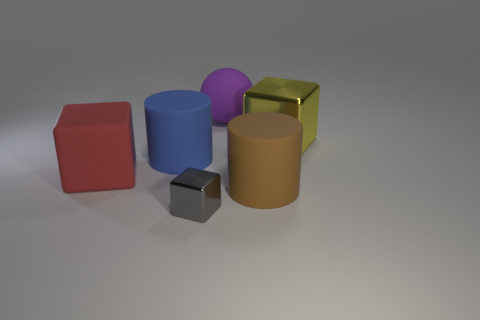What material is the large cylinder that is to the left of the big purple sphere?
Ensure brevity in your answer.  Rubber. Does the object that is on the right side of the brown cylinder have the same shape as the purple thing?
Provide a succinct answer. No. Is there a shiny thing of the same size as the matte ball?
Your answer should be compact. Yes. Is the shape of the small thing the same as the metal thing behind the large brown rubber thing?
Keep it short and to the point. Yes. Are there fewer large brown cylinders that are in front of the big purple rubber object than red rubber balls?
Provide a succinct answer. No. Do the big purple matte object and the large yellow thing have the same shape?
Provide a succinct answer. No. There is a blue cylinder that is made of the same material as the big red cube; what is its size?
Ensure brevity in your answer.  Large. Are there fewer small spheres than large yellow cubes?
Make the answer very short. Yes. How many small things are either brown shiny objects or purple matte things?
Give a very brief answer. 0. How many cubes are behind the brown rubber thing and to the left of the yellow object?
Provide a short and direct response. 1. 